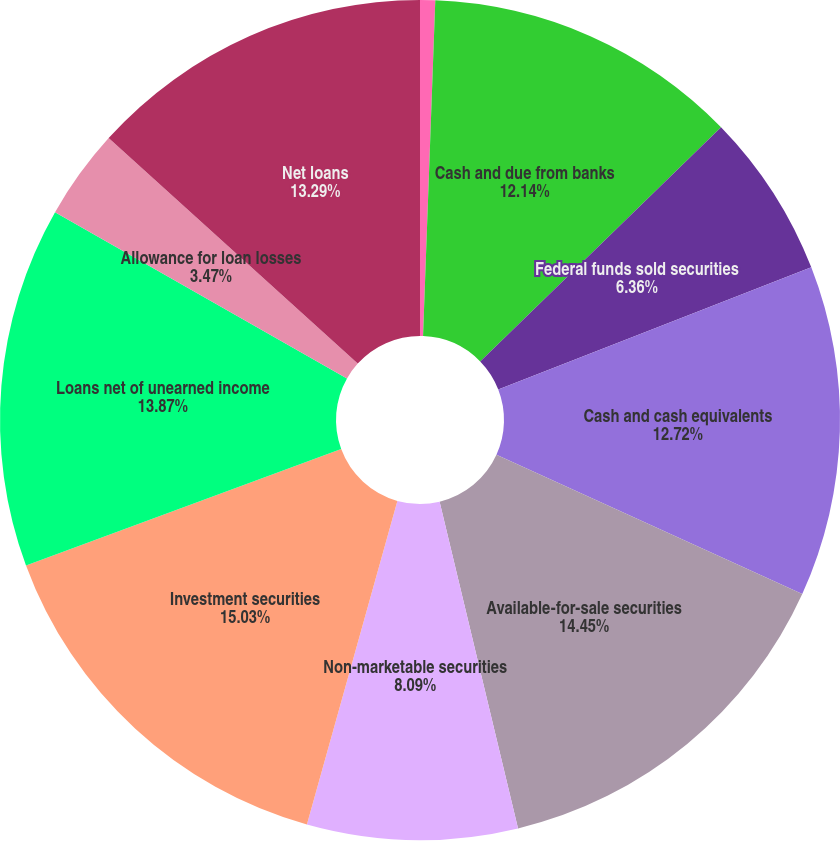Convert chart to OTSL. <chart><loc_0><loc_0><loc_500><loc_500><pie_chart><fcel>(Dollars in thousands except<fcel>Cash and due from banks<fcel>Federal funds sold securities<fcel>Cash and cash equivalents<fcel>Available-for-sale securities<fcel>Non-marketable securities<fcel>Investment securities<fcel>Loans net of unearned income<fcel>Allowance for loan losses<fcel>Net loans<nl><fcel>0.58%<fcel>12.14%<fcel>6.36%<fcel>12.72%<fcel>14.45%<fcel>8.09%<fcel>15.03%<fcel>13.87%<fcel>3.47%<fcel>13.29%<nl></chart> 